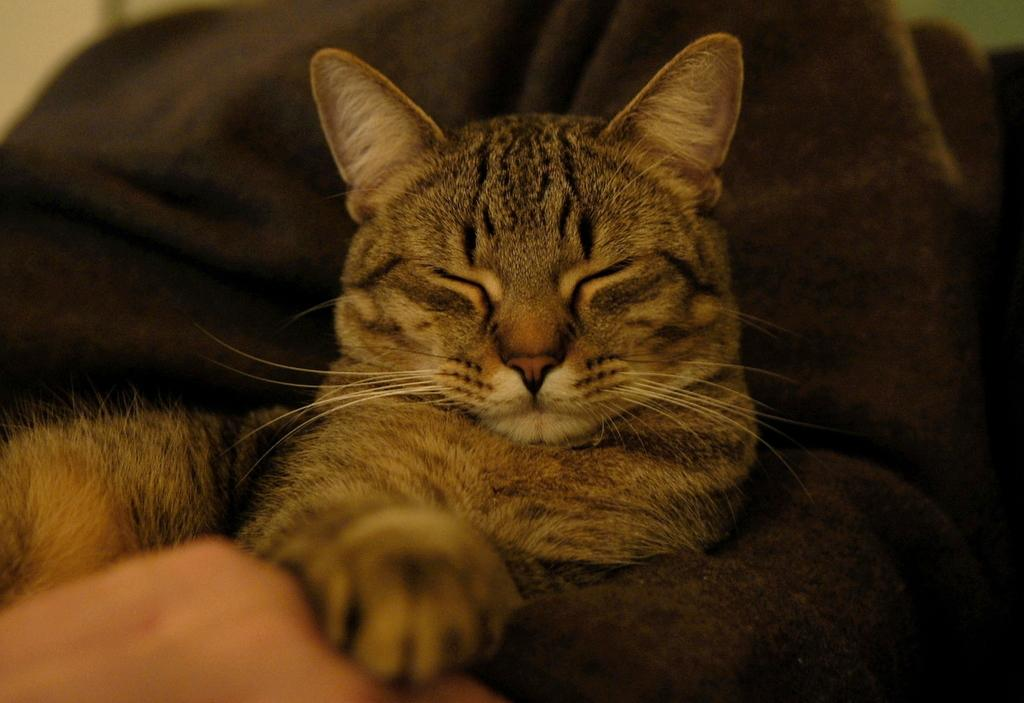What type of animal is in the image? There is a cat in the image. Where is the cat located? The cat is on a sofa. What can be seen in the background of the image? There is a wall visible in the background of the image. How many apples are on the roof in the image? There are no apples or roof present in the image. What type of pets are visible in the image? There is only one pet visible in the image, which is a cat. 